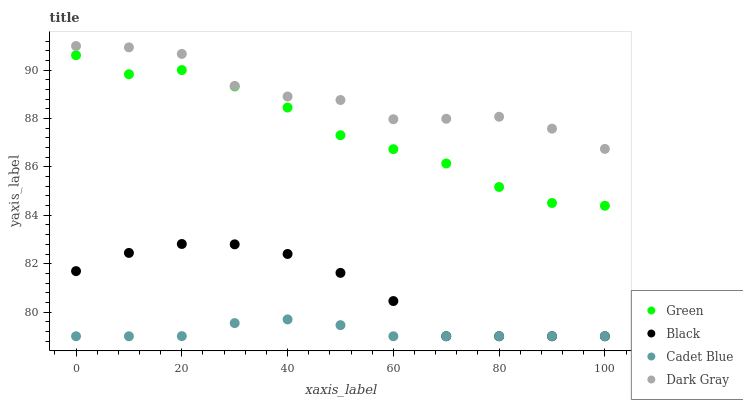Does Cadet Blue have the minimum area under the curve?
Answer yes or no. Yes. Does Dark Gray have the maximum area under the curve?
Answer yes or no. Yes. Does Black have the minimum area under the curve?
Answer yes or no. No. Does Black have the maximum area under the curve?
Answer yes or no. No. Is Cadet Blue the smoothest?
Answer yes or no. Yes. Is Dark Gray the roughest?
Answer yes or no. Yes. Is Black the smoothest?
Answer yes or no. No. Is Black the roughest?
Answer yes or no. No. Does Black have the lowest value?
Answer yes or no. Yes. Does Green have the lowest value?
Answer yes or no. No. Does Dark Gray have the highest value?
Answer yes or no. Yes. Does Black have the highest value?
Answer yes or no. No. Is Black less than Dark Gray?
Answer yes or no. Yes. Is Dark Gray greater than Black?
Answer yes or no. Yes. Does Black intersect Cadet Blue?
Answer yes or no. Yes. Is Black less than Cadet Blue?
Answer yes or no. No. Is Black greater than Cadet Blue?
Answer yes or no. No. Does Black intersect Dark Gray?
Answer yes or no. No. 